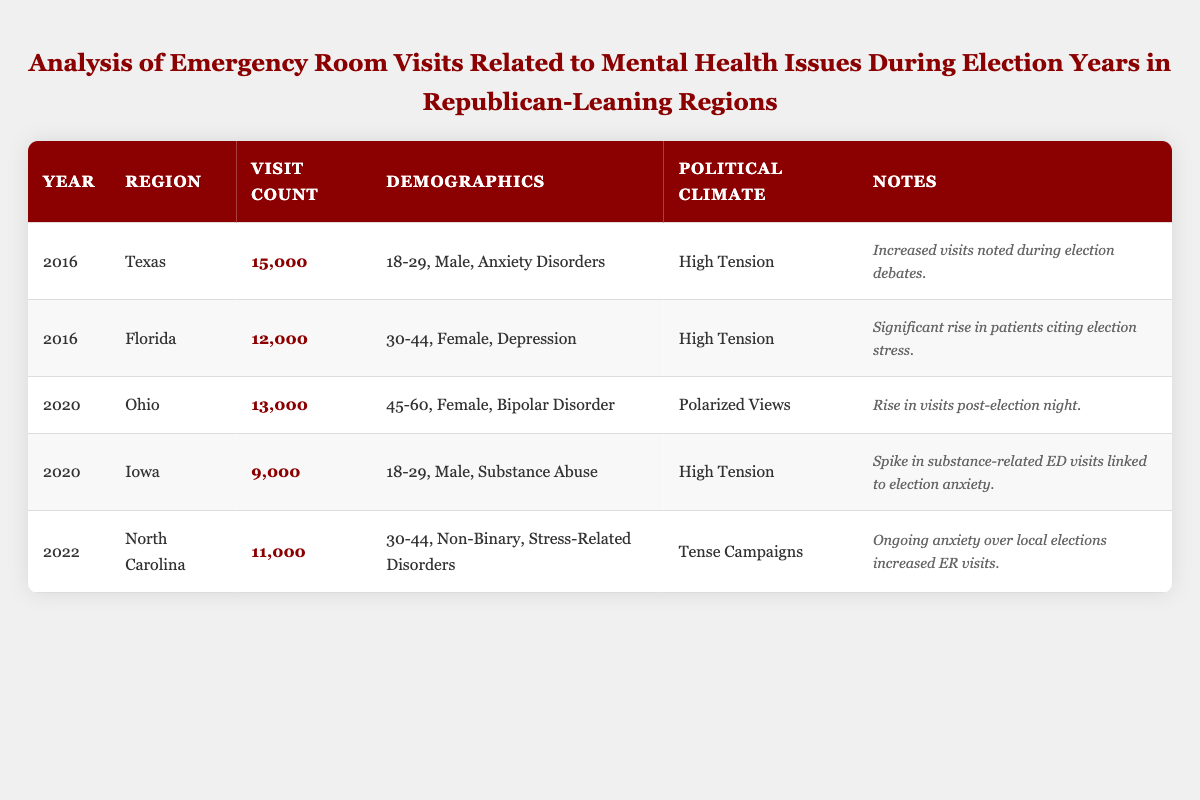What was the visit count for mental health issues in Texas in 2016? The table shows the visit count for Texas in 2016 as 15,000.
Answer: 15,000 Which region had the highest visit count for mental health issues in 2016? The table indicates that Texas had the highest visit count in 2016 with 15,000 visits compared to Florida with 12,000 visits.
Answer: Texas How many total emergency room visits were there related to mental health issues during the election years of 2016 and 2020? The visit counts for 2016 are 15,000 (Texas) + 12,000 (Florida) = 27,000 and for 2020, it's 13,000 (Ohio) + 9,000 (Iowa) = 22,000. The total is 27,000 + 22,000 = 49,000.
Answer: 49,000 Is there a difference in the age group of the highest visit counts in 2016 compared to 2020? In 2016, the highest visit count was for the 18-29 age group in Texas, while in 2020, the highest count was for the 45-60 age group in Ohio. Thus, there is a difference in age groups.
Answer: Yes What were the most common diagnoses associated with emergency room visits during the election years analyzed? The diagnoses listed include Anxiety Disorders (2016, Texas), Depression (2016, Florida), Bipolar Disorder (2020, Ohio), Substance Abuse (2020, Iowa), and Stress-Related Disorders (2022, North Carolina). There was no one common diagnosis that predominates across years, differing based on region and year.
Answer: No common diagnosis Which political climate had the most emergency room visits documented and how does it compare with others? High Tension was present in two instances (Texas 2016 and Iowa 2020) with 15,000 and 9,000 visits respectively. Polarized Views had 13,000 visits. High Tension thus had a higher overall impact.
Answer: High Tension How did the visit counts in Florida in 2016 compare to those in North Carolina in 2022? Florida had 12,000 visits in 2016 while North Carolina had 11,000 visits in 2022, showing that Florida had a higher visit count.
Answer: Florida had a higher count Which year showed the most diverse range of demographics in the visit data? Analyzing the demographics per year, 2020 presented visits from multiple age groups and genders, including males, females, and non-binary individuals, indicating a wider diversity compared to other years.
Answer: 2020 